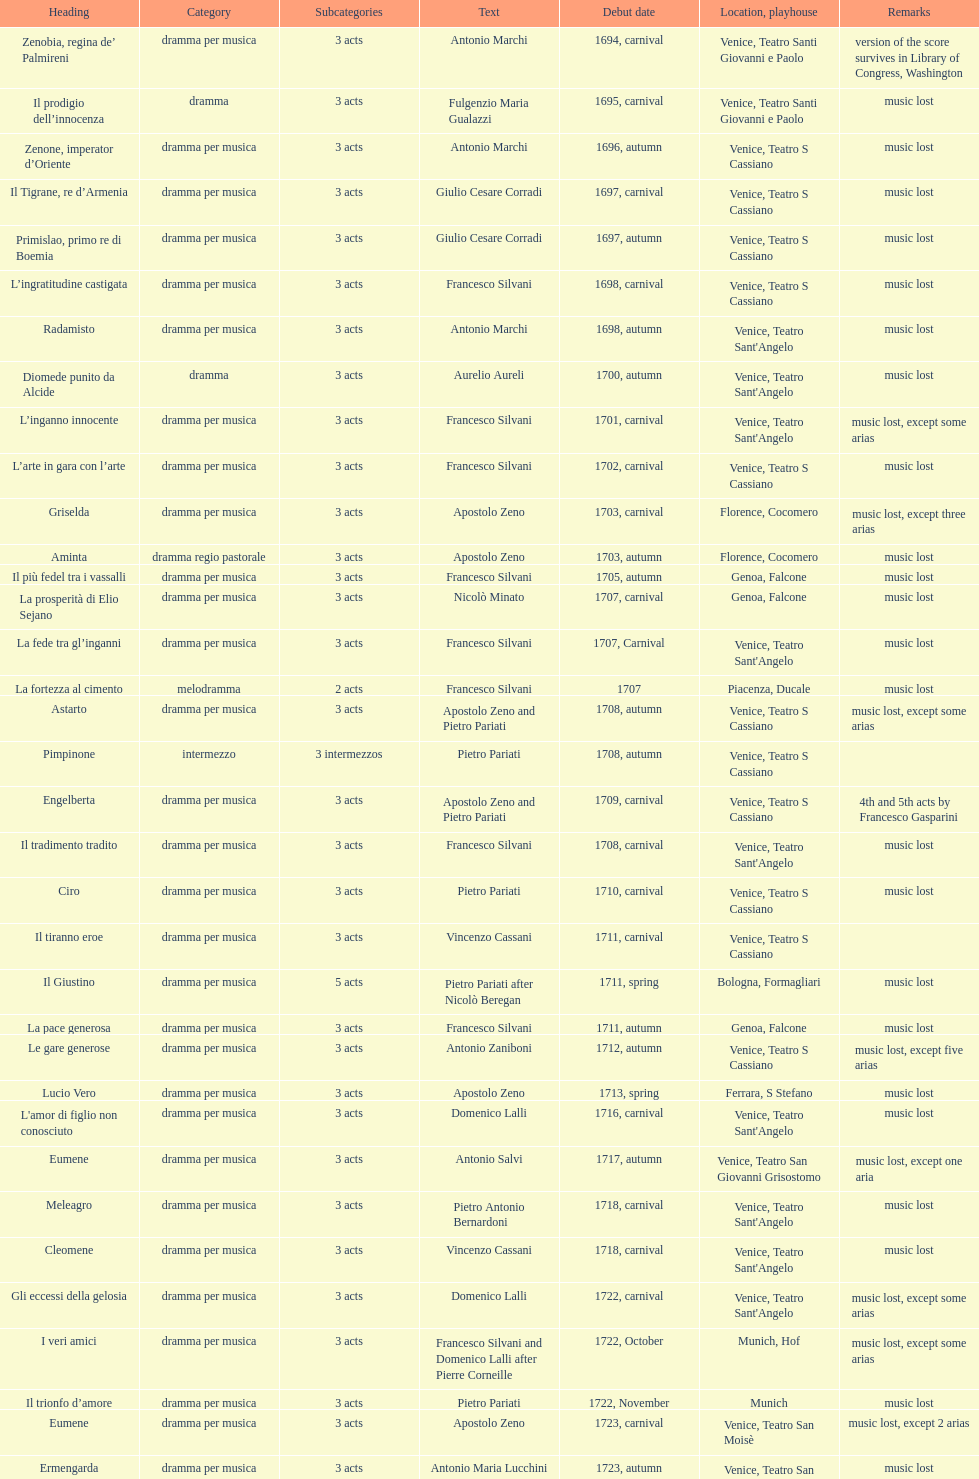Which title premiered directly after candalide? Artamene. 